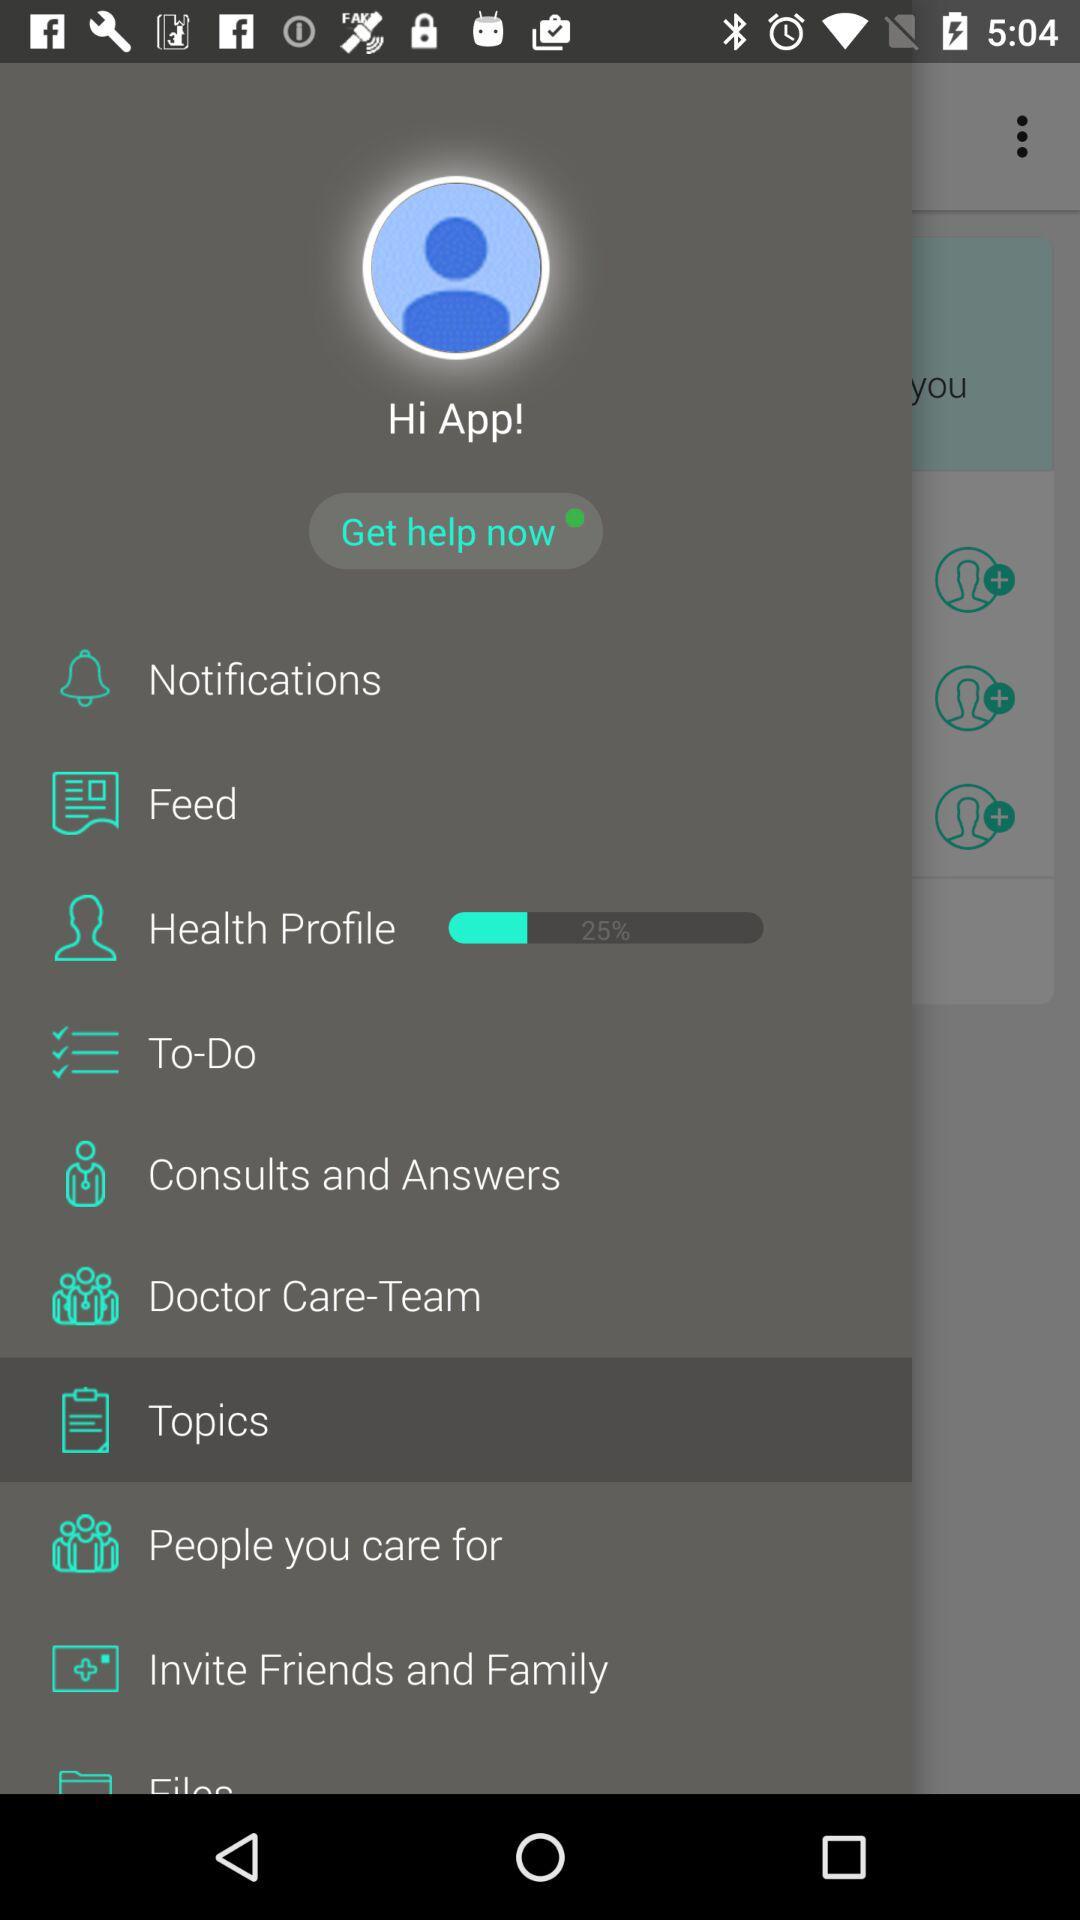What percentage of the health profile is complete? The health profile is 25% complete. 